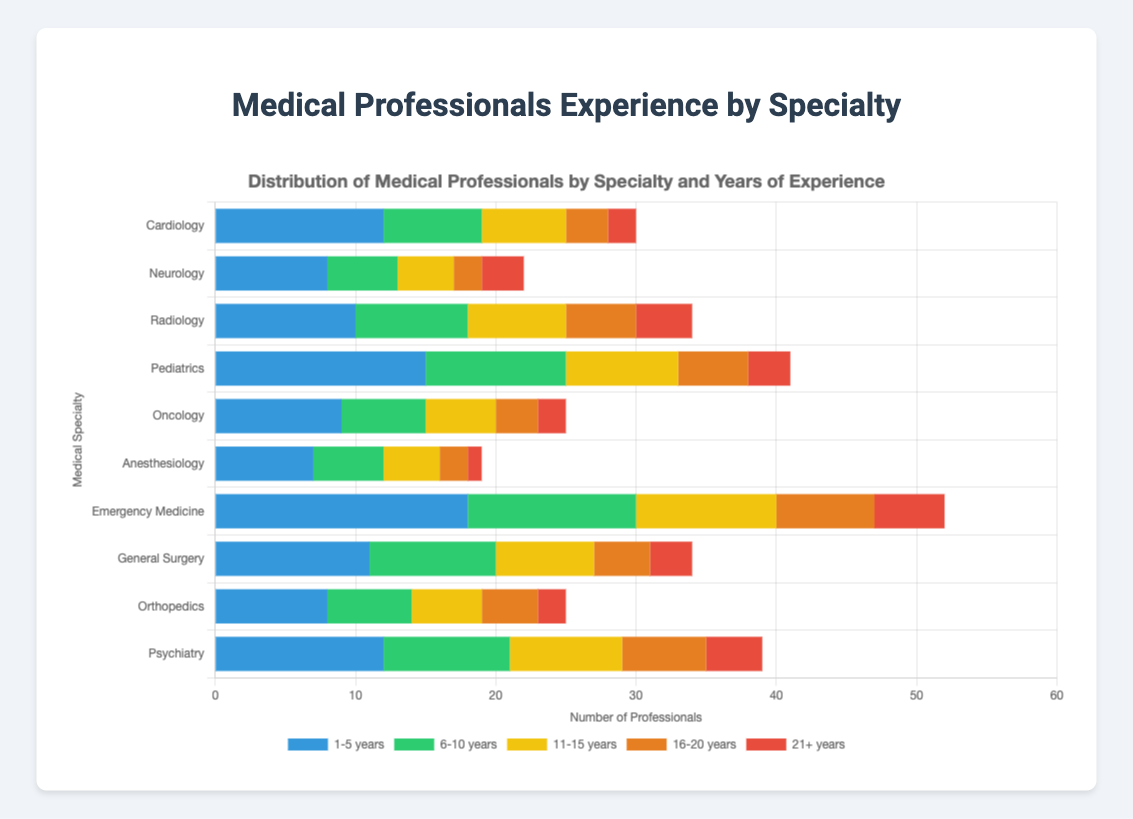What specialty has the highest number of medical professionals with 1-5 years of experience? Look at the bar segments representing "1-5 years" across all specialties and identify the one that appears the longest. The "1-5 years" segments are represented by the blue color. The Pediatrics specialty has the longest blue segment with 15 professionals.
Answer: Pediatrics Which specialty has more professionals with 11-15 years of experience, Cardiology or General Surgery? Compare the lengths of the yellow segments for Cardiology and General Surgery. Cardiology has 6 professionals with 11-15 years of experience, whereas General Surgery has 7.
Answer: General Surgery What is the total number of medical professionals in Radiology with up to 10 years of experience? Sum the number of professionals in Radiology with 1-5 years and 6-10 years of experience: 10 + 8.
Answer: 18 Which specialty has more professionals with 16+ years of experience, Neurology or Orthopedics? Add the number of professionals with 16-20 years and 21+ years for both specialties. Neurology: 2 + 3 = 5, Orthopedics: 4 + 2 = 6.
Answer: Orthopedics What is the combined number of medical professionals in Emergency Medicine with 6-10 years and 21+ years of experience? Sum the number of professionals with 6-10 years and 21+ years of experience in Emergency Medicine: 12 + 5.
Answer: 17 Which specialty has the least number of medical professionals with 21+ years of experience? Look at the red segments representing "21+ years" across all specialties and identify the one that appears the shortest. Anesthesiology has the shortest red segment with 1 professional.
Answer: Anesthesiology What is the total number of medical professionals in Oncology and Psychiatry with 16-20 years of experience? Add the number of professionals with 16-20 years of experience in Oncology and Psychiatry: 3 + 6.
Answer: 9 Which specialty has a greater number of professionals with 1-5 years of experience compared to 6-10 years of experience? Compare the lengths of the blue and green segments within each specialty. Pediatrics has 15 (1-5 years) compared to 10 (6-10 years).
Answer: Pediatrics What is the total number of medical professionals in Cardiology, Neurology, and Radiology? Sum the total medical professionals in each of the three specialties: (12+7+6+3+2) + (8+5+4+2+3) + (10+8+7+5+4).
Answer: 76 Which specialty has the highest average years of experience distribution among the categories presented? For each specialty, sum the years of experience weighted by their corresponding number of professionals and then compute the average. Here, we identify Pediatrics with a high number of seasoned professionals, contributing to a higher overall average. Detailed steps include calculating weighted averages for each category.
Answer: Pediatrics 